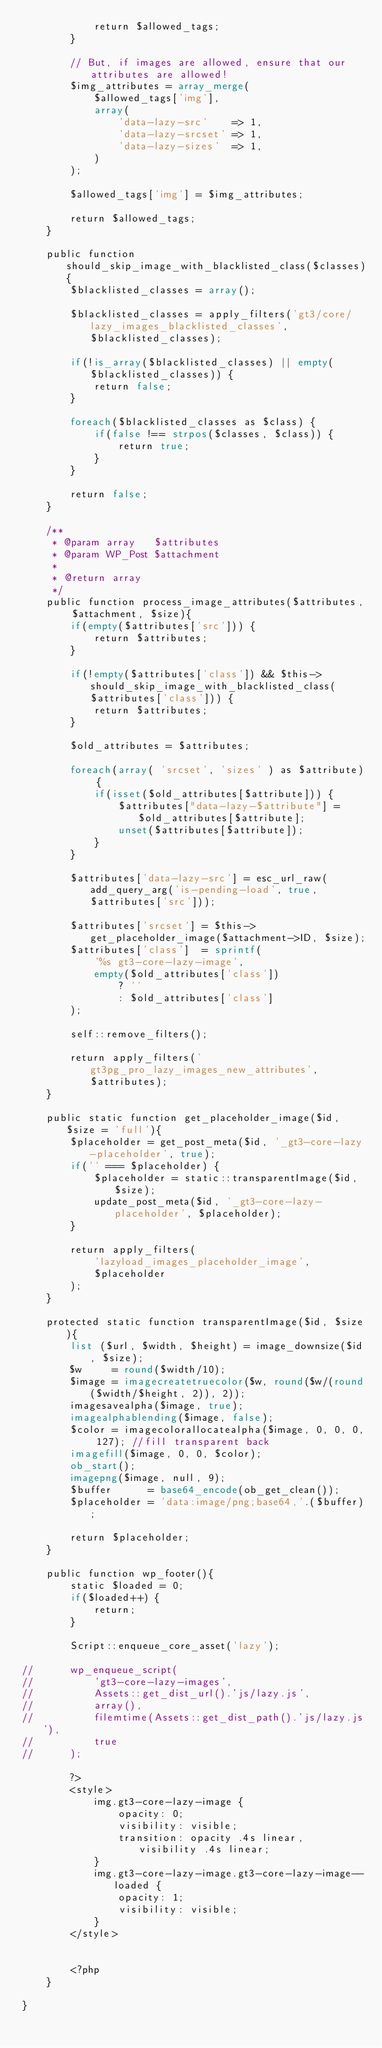<code> <loc_0><loc_0><loc_500><loc_500><_PHP_>			return $allowed_tags;
		}

		// But, if images are allowed, ensure that our attributes are allowed!
		$img_attributes = array_merge(
			$allowed_tags['img'],
			array(
				'data-lazy-src'    => 1,
				'data-lazy-srcset' => 1,
				'data-lazy-sizes'  => 1,
			)
		);

		$allowed_tags['img'] = $img_attributes;

		return $allowed_tags;
	}

	public function should_skip_image_with_blacklisted_class($classes){
		$blacklisted_classes = array();

		$blacklisted_classes = apply_filters('gt3/core/lazy_images_blacklisted_classes', $blacklisted_classes);

		if(!is_array($blacklisted_classes) || empty($blacklisted_classes)) {
			return false;
		}

		foreach($blacklisted_classes as $class) {
			if(false !== strpos($classes, $class)) {
				return true;
			}
		}

		return false;
	}

	/**
	 * @param array   $attributes
	 * @param WP_Post $attachment
	 *
	 * @return array
	 */
	public function process_image_attributes($attributes, $attachment, $size){
		if(empty($attributes['src'])) {
			return $attributes;
		}

		if(!empty($attributes['class']) && $this->should_skip_image_with_blacklisted_class($attributes['class'])) {
			return $attributes;
		}

		$old_attributes = $attributes;

		foreach(array( 'srcset', 'sizes' ) as $attribute) {
			if(isset($old_attributes[$attribute])) {
				$attributes["data-lazy-$attribute"] = $old_attributes[$attribute];
				unset($attributes[$attribute]);
			}
		}

		$attributes['data-lazy-src'] = esc_url_raw(add_query_arg('is-pending-load', true, $attributes['src']));

		$attributes['srcset'] = $this->get_placeholder_image($attachment->ID, $size);
		$attributes['class']  = sprintf(
			'%s gt3-core-lazy-image',
			empty($old_attributes['class'])
				? ''
				: $old_attributes['class']
		);

		self::remove_filters();

		return apply_filters('gt3pg_pro_lazy_images_new_attributes', $attributes);
	}

	public static function get_placeholder_image($id, $size = 'full'){
		$placeholder = get_post_meta($id, '_gt3-core-lazy-placeholder', true);
		if('' === $placeholder) {
			$placeholder = static::transparentImage($id, $size);
			update_post_meta($id, '_gt3-core-lazy-placeholder', $placeholder);
		}

		return apply_filters(
			'lazyload_images_placeholder_image',
			$placeholder
		);
	}

	protected static function transparentImage($id, $size){
		list ($url, $width, $height) = image_downsize($id, $size);
		$w     = round($width/10);
		$image = imagecreatetruecolor($w, round($w/(round($width/$height, 2)), 2));
		imagesavealpha($image, true);
		imagealphablending($image, false);
		$color = imagecolorallocatealpha($image, 0, 0, 0, 127); //fill transparent back
		imagefill($image, 0, 0, $color);
		ob_start();
		imagepng($image, null, 9);
		$buffer      = base64_encode(ob_get_clean());
		$placeholder = 'data:image/png;base64,'.($buffer);

		return $placeholder;
	}

	public function wp_footer(){
		static $loaded = 0;
		if($loaded++) {
			return;
		}

		Script::enqueue_core_asset('lazy');

//		wp_enqueue_script(
//			'gt3-core-lazy-images',
//			Assets::get_dist_url().'js/lazy.js',
//			array(),
//			filemtime(Assets::get_dist_path().'js/lazy.js'),
//			true
//		);

		?>
		<style>
			img.gt3-core-lazy-image {
				opacity: 0;
				visibility: visible;
				transition: opacity .4s linear, visibility .4s linear;
			}
			img.gt3-core-lazy-image.gt3-core-lazy-image--loaded {
				opacity: 1;
				visibility: visible;
			}
		</style>


		<?php
	}

}
</code> 